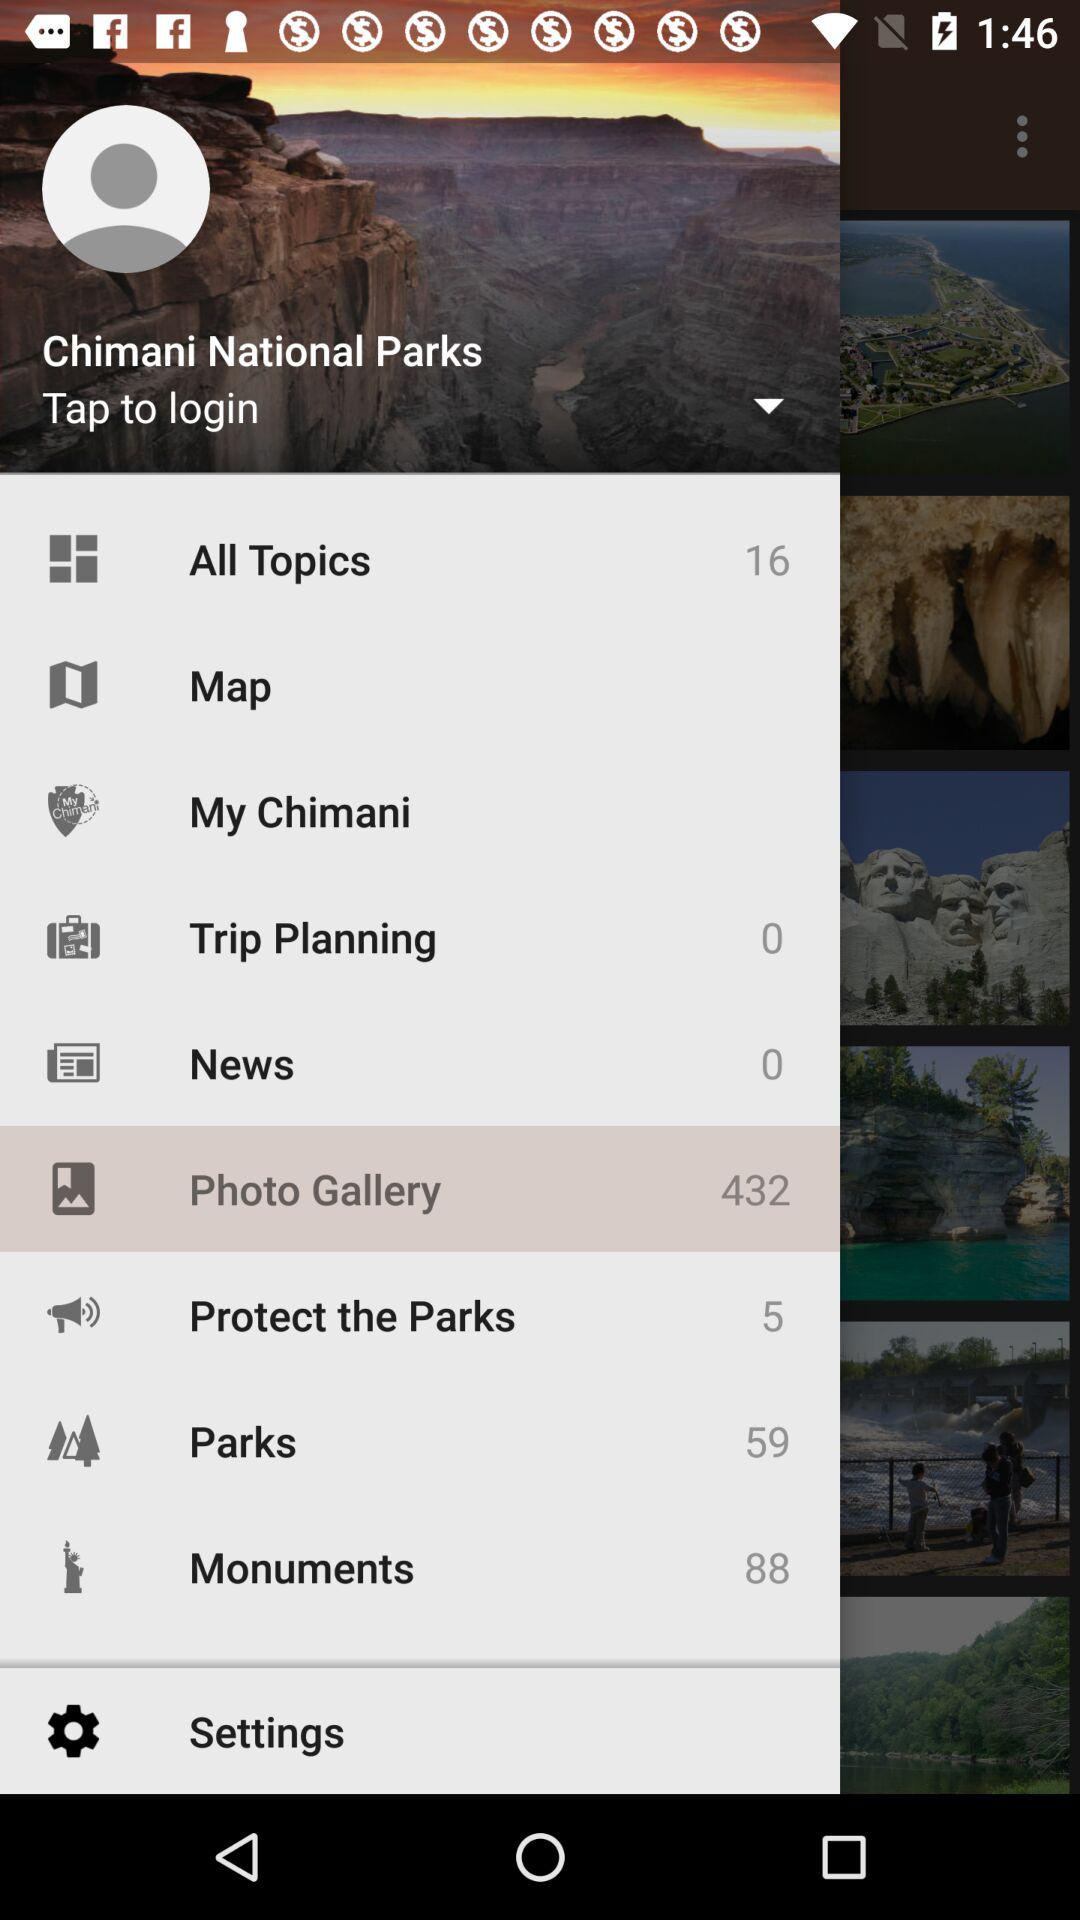How many topics are there? There are 16 topics. 